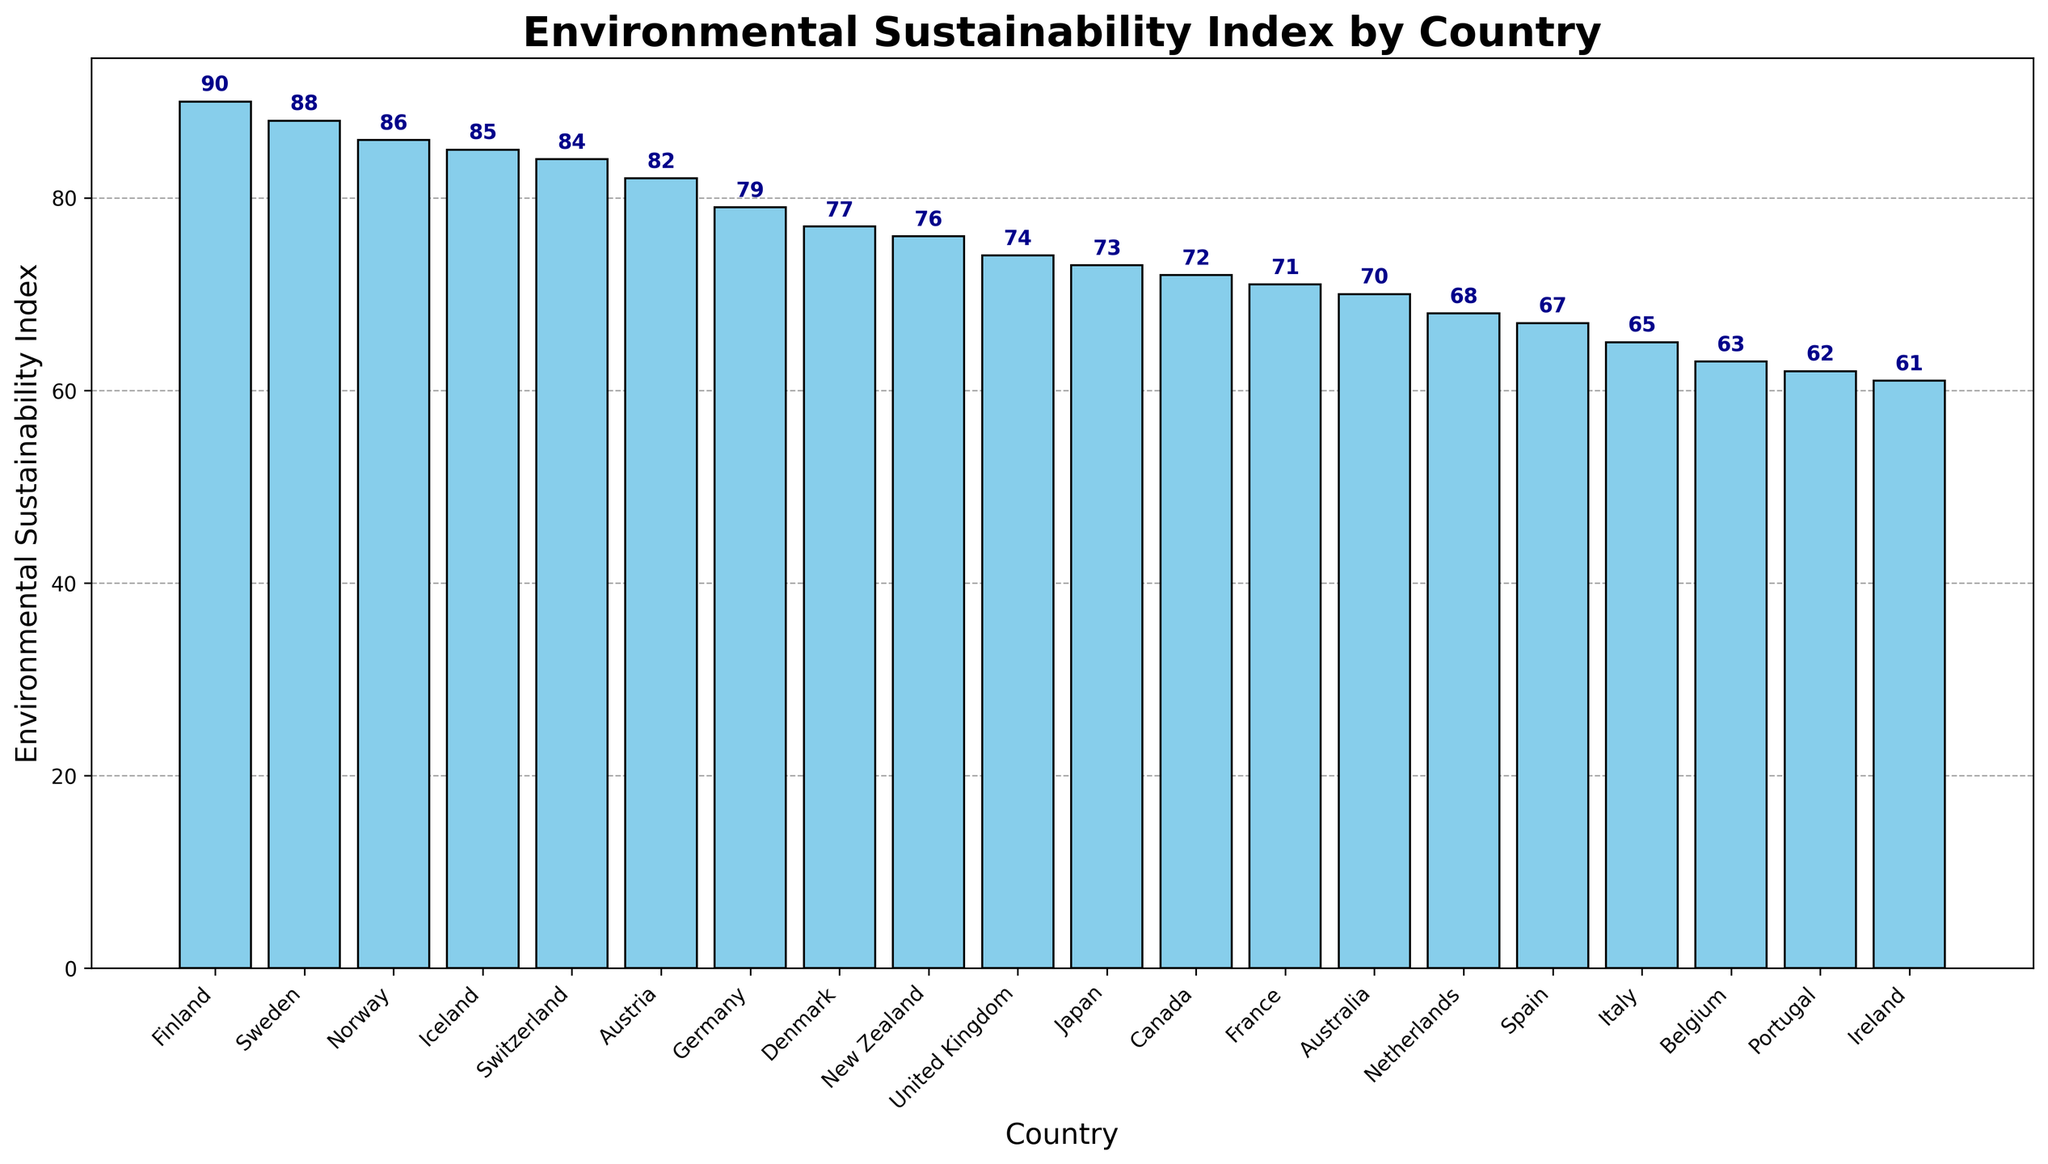Which country has the highest Environmental Sustainability Index? Observing the bar chart, the highest bar corresponds to Finland with an Environmental Sustainability Index of 90.
Answer: Finland Which two countries have the closest Environmental Sustainability Index values? By examining the heights of the bars, Sweden (88) and Norway (86) seem to have the most similar Environmental Sustainability Index values, differing by only 2.
Answer: Sweden and Norway What is the average Environmental Sustainability Index of the Scandinavian countries listed? The Scandinavian countries listed are Finland (90), Sweden (88), Norway (86), and Denmark (77). Summing these values gives 341, and the average is 341 / 4 = 85.25.
Answer: 85.25 Which country's Environmental Sustainability Index is exactly half of Finland's? Finland's index is 90, so half of that value is 45. There is no country with an index of 45 in the chart, so the answer is none.
Answer: None How many countries have an Environmental Sustainability Index above 80? By counting the bars with values above 80, the countries are Finland (90), Sweden (88), Norway (86), Iceland (85), Switzerland (84), and Austria (82). There are 6 countries in total.
Answer: 6 Which country has an Environmental Sustainability Index lower than Spain but higher than Ireland? Spain has an index of 67, and Ireland has 61. Italy, with an index of 65, fits this criterion.
Answer: Italy Is there a country with an Environmental Sustainability Index of 70? Inspecting the values on the chart, Australia has an Environmental Sustainability Index of 70.
Answer: Australia What is the difference in the Environmental Sustainability Index between Germany and Japan? Germany has an index of 79 and Japan has 73. The difference is 79 - 73 = 6.
Answer: 6 Which country has the smallest Environmental Sustainability Index? By looking at the shortest bar, the smallest Environmental Sustainability Index belongs to Ireland with a value of 61.
Answer: Ireland What is the median Environmental Sustainability Index value for the countries listed? The sorted values of the indexes are 61, 62, 63, 65, 67, 68, 70, 71, 72, 73, 74, 76, 77, 79, 82, 84, 85, 86, 88, 90. With 20 countries, the median is the average of the 10th and 11th values, so (73 + 74) / 2 = 73.5.
Answer: 73.5 